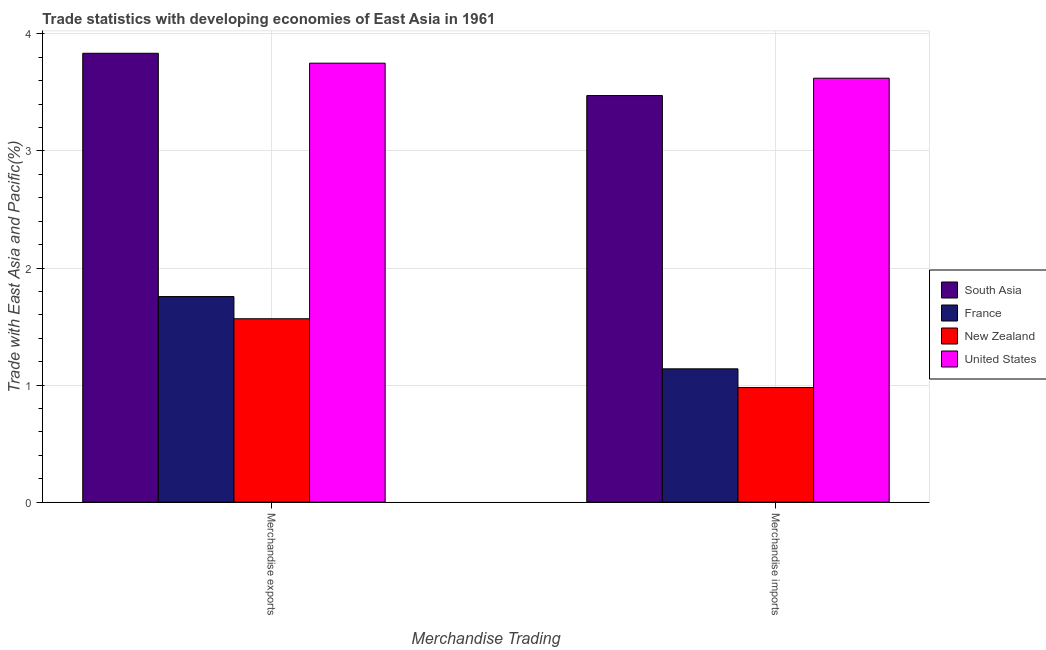Are the number of bars on each tick of the X-axis equal?
Ensure brevity in your answer.  Yes. What is the label of the 2nd group of bars from the left?
Your response must be concise. Merchandise imports. What is the merchandise exports in South Asia?
Your response must be concise. 3.83. Across all countries, what is the maximum merchandise exports?
Offer a very short reply. 3.83. Across all countries, what is the minimum merchandise exports?
Provide a short and direct response. 1.57. In which country was the merchandise imports minimum?
Provide a succinct answer. New Zealand. What is the total merchandise imports in the graph?
Ensure brevity in your answer.  9.21. What is the difference between the merchandise exports in France and that in South Asia?
Offer a very short reply. -2.08. What is the difference between the merchandise imports in France and the merchandise exports in United States?
Your response must be concise. -2.61. What is the average merchandise imports per country?
Provide a succinct answer. 2.3. What is the difference between the merchandise exports and merchandise imports in France?
Give a very brief answer. 0.62. What is the ratio of the merchandise exports in New Zealand to that in South Asia?
Keep it short and to the point. 0.41. How many bars are there?
Your response must be concise. 8. Are all the bars in the graph horizontal?
Provide a short and direct response. No. How many countries are there in the graph?
Your response must be concise. 4. What is the difference between two consecutive major ticks on the Y-axis?
Keep it short and to the point. 1. Are the values on the major ticks of Y-axis written in scientific E-notation?
Provide a short and direct response. No. Does the graph contain any zero values?
Keep it short and to the point. No. Where does the legend appear in the graph?
Your response must be concise. Center right. How many legend labels are there?
Offer a very short reply. 4. What is the title of the graph?
Provide a succinct answer. Trade statistics with developing economies of East Asia in 1961. What is the label or title of the X-axis?
Provide a succinct answer. Merchandise Trading. What is the label or title of the Y-axis?
Keep it short and to the point. Trade with East Asia and Pacific(%). What is the Trade with East Asia and Pacific(%) of South Asia in Merchandise exports?
Your response must be concise. 3.83. What is the Trade with East Asia and Pacific(%) of France in Merchandise exports?
Make the answer very short. 1.76. What is the Trade with East Asia and Pacific(%) in New Zealand in Merchandise exports?
Make the answer very short. 1.57. What is the Trade with East Asia and Pacific(%) of United States in Merchandise exports?
Your response must be concise. 3.75. What is the Trade with East Asia and Pacific(%) of South Asia in Merchandise imports?
Your answer should be very brief. 3.47. What is the Trade with East Asia and Pacific(%) of France in Merchandise imports?
Your response must be concise. 1.14. What is the Trade with East Asia and Pacific(%) of New Zealand in Merchandise imports?
Provide a succinct answer. 0.98. What is the Trade with East Asia and Pacific(%) in United States in Merchandise imports?
Ensure brevity in your answer.  3.62. Across all Merchandise Trading, what is the maximum Trade with East Asia and Pacific(%) in South Asia?
Offer a very short reply. 3.83. Across all Merchandise Trading, what is the maximum Trade with East Asia and Pacific(%) in France?
Make the answer very short. 1.76. Across all Merchandise Trading, what is the maximum Trade with East Asia and Pacific(%) in New Zealand?
Offer a terse response. 1.57. Across all Merchandise Trading, what is the maximum Trade with East Asia and Pacific(%) of United States?
Your response must be concise. 3.75. Across all Merchandise Trading, what is the minimum Trade with East Asia and Pacific(%) in South Asia?
Your response must be concise. 3.47. Across all Merchandise Trading, what is the minimum Trade with East Asia and Pacific(%) of France?
Keep it short and to the point. 1.14. Across all Merchandise Trading, what is the minimum Trade with East Asia and Pacific(%) of New Zealand?
Offer a terse response. 0.98. Across all Merchandise Trading, what is the minimum Trade with East Asia and Pacific(%) in United States?
Make the answer very short. 3.62. What is the total Trade with East Asia and Pacific(%) of South Asia in the graph?
Provide a short and direct response. 7.31. What is the total Trade with East Asia and Pacific(%) of France in the graph?
Offer a terse response. 2.89. What is the total Trade with East Asia and Pacific(%) in New Zealand in the graph?
Ensure brevity in your answer.  2.55. What is the total Trade with East Asia and Pacific(%) of United States in the graph?
Provide a short and direct response. 7.37. What is the difference between the Trade with East Asia and Pacific(%) of South Asia in Merchandise exports and that in Merchandise imports?
Provide a succinct answer. 0.36. What is the difference between the Trade with East Asia and Pacific(%) of France in Merchandise exports and that in Merchandise imports?
Keep it short and to the point. 0.62. What is the difference between the Trade with East Asia and Pacific(%) of New Zealand in Merchandise exports and that in Merchandise imports?
Offer a very short reply. 0.59. What is the difference between the Trade with East Asia and Pacific(%) in United States in Merchandise exports and that in Merchandise imports?
Offer a terse response. 0.13. What is the difference between the Trade with East Asia and Pacific(%) of South Asia in Merchandise exports and the Trade with East Asia and Pacific(%) of France in Merchandise imports?
Ensure brevity in your answer.  2.7. What is the difference between the Trade with East Asia and Pacific(%) of South Asia in Merchandise exports and the Trade with East Asia and Pacific(%) of New Zealand in Merchandise imports?
Give a very brief answer. 2.86. What is the difference between the Trade with East Asia and Pacific(%) in South Asia in Merchandise exports and the Trade with East Asia and Pacific(%) in United States in Merchandise imports?
Your response must be concise. 0.21. What is the difference between the Trade with East Asia and Pacific(%) in France in Merchandise exports and the Trade with East Asia and Pacific(%) in New Zealand in Merchandise imports?
Keep it short and to the point. 0.78. What is the difference between the Trade with East Asia and Pacific(%) of France in Merchandise exports and the Trade with East Asia and Pacific(%) of United States in Merchandise imports?
Your answer should be very brief. -1.87. What is the difference between the Trade with East Asia and Pacific(%) of New Zealand in Merchandise exports and the Trade with East Asia and Pacific(%) of United States in Merchandise imports?
Your answer should be compact. -2.06. What is the average Trade with East Asia and Pacific(%) of South Asia per Merchandise Trading?
Provide a succinct answer. 3.65. What is the average Trade with East Asia and Pacific(%) in France per Merchandise Trading?
Your answer should be compact. 1.45. What is the average Trade with East Asia and Pacific(%) of New Zealand per Merchandise Trading?
Offer a very short reply. 1.27. What is the average Trade with East Asia and Pacific(%) in United States per Merchandise Trading?
Your answer should be very brief. 3.69. What is the difference between the Trade with East Asia and Pacific(%) in South Asia and Trade with East Asia and Pacific(%) in France in Merchandise exports?
Provide a succinct answer. 2.08. What is the difference between the Trade with East Asia and Pacific(%) in South Asia and Trade with East Asia and Pacific(%) in New Zealand in Merchandise exports?
Your answer should be compact. 2.27. What is the difference between the Trade with East Asia and Pacific(%) in South Asia and Trade with East Asia and Pacific(%) in United States in Merchandise exports?
Ensure brevity in your answer.  0.08. What is the difference between the Trade with East Asia and Pacific(%) of France and Trade with East Asia and Pacific(%) of New Zealand in Merchandise exports?
Make the answer very short. 0.19. What is the difference between the Trade with East Asia and Pacific(%) in France and Trade with East Asia and Pacific(%) in United States in Merchandise exports?
Offer a very short reply. -1.99. What is the difference between the Trade with East Asia and Pacific(%) of New Zealand and Trade with East Asia and Pacific(%) of United States in Merchandise exports?
Give a very brief answer. -2.18. What is the difference between the Trade with East Asia and Pacific(%) of South Asia and Trade with East Asia and Pacific(%) of France in Merchandise imports?
Provide a succinct answer. 2.33. What is the difference between the Trade with East Asia and Pacific(%) of South Asia and Trade with East Asia and Pacific(%) of New Zealand in Merchandise imports?
Make the answer very short. 2.49. What is the difference between the Trade with East Asia and Pacific(%) in South Asia and Trade with East Asia and Pacific(%) in United States in Merchandise imports?
Offer a very short reply. -0.15. What is the difference between the Trade with East Asia and Pacific(%) of France and Trade with East Asia and Pacific(%) of New Zealand in Merchandise imports?
Your answer should be very brief. 0.16. What is the difference between the Trade with East Asia and Pacific(%) of France and Trade with East Asia and Pacific(%) of United States in Merchandise imports?
Give a very brief answer. -2.48. What is the difference between the Trade with East Asia and Pacific(%) of New Zealand and Trade with East Asia and Pacific(%) of United States in Merchandise imports?
Ensure brevity in your answer.  -2.64. What is the ratio of the Trade with East Asia and Pacific(%) in South Asia in Merchandise exports to that in Merchandise imports?
Offer a very short reply. 1.1. What is the ratio of the Trade with East Asia and Pacific(%) in France in Merchandise exports to that in Merchandise imports?
Your answer should be very brief. 1.54. What is the ratio of the Trade with East Asia and Pacific(%) of New Zealand in Merchandise exports to that in Merchandise imports?
Provide a succinct answer. 1.6. What is the ratio of the Trade with East Asia and Pacific(%) in United States in Merchandise exports to that in Merchandise imports?
Your answer should be compact. 1.04. What is the difference between the highest and the second highest Trade with East Asia and Pacific(%) of South Asia?
Keep it short and to the point. 0.36. What is the difference between the highest and the second highest Trade with East Asia and Pacific(%) of France?
Make the answer very short. 0.62. What is the difference between the highest and the second highest Trade with East Asia and Pacific(%) in New Zealand?
Your response must be concise. 0.59. What is the difference between the highest and the second highest Trade with East Asia and Pacific(%) in United States?
Offer a terse response. 0.13. What is the difference between the highest and the lowest Trade with East Asia and Pacific(%) in South Asia?
Make the answer very short. 0.36. What is the difference between the highest and the lowest Trade with East Asia and Pacific(%) of France?
Ensure brevity in your answer.  0.62. What is the difference between the highest and the lowest Trade with East Asia and Pacific(%) in New Zealand?
Your answer should be compact. 0.59. What is the difference between the highest and the lowest Trade with East Asia and Pacific(%) in United States?
Your answer should be very brief. 0.13. 